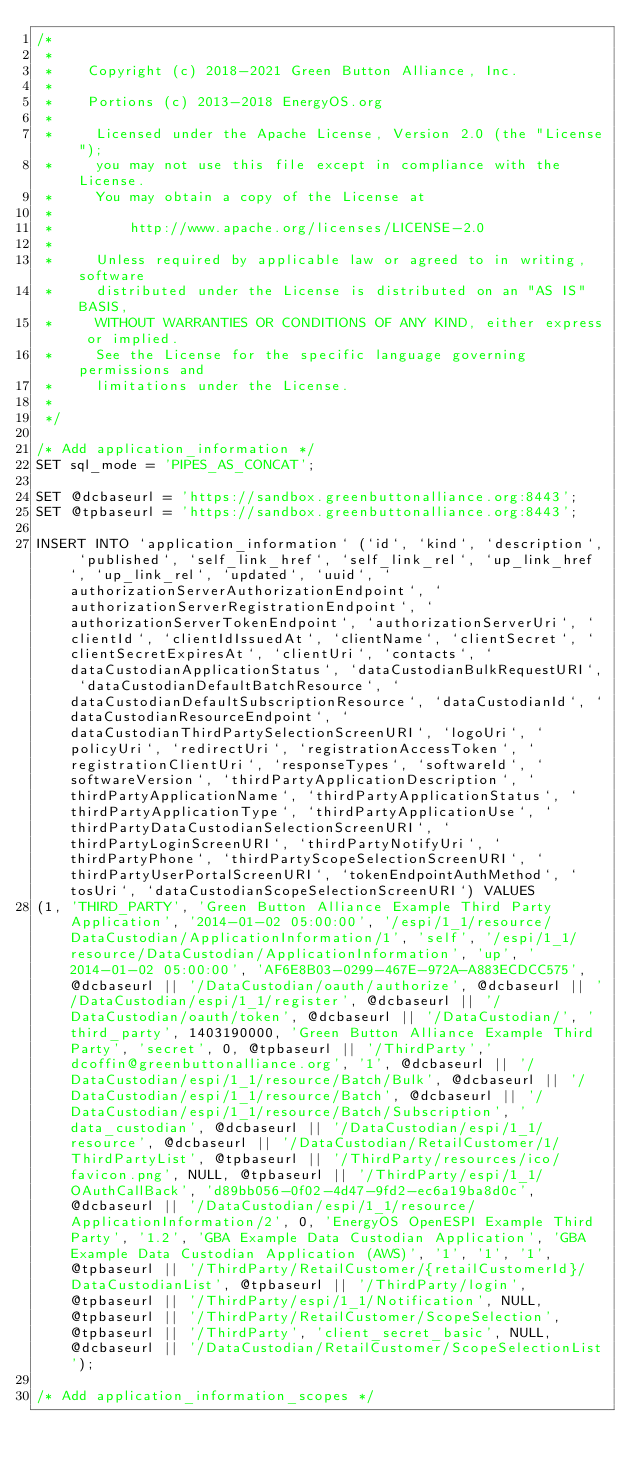<code> <loc_0><loc_0><loc_500><loc_500><_SQL_>/*
 *
 *    Copyright (c) 2018-2021 Green Button Alliance, Inc.
 *
 *    Portions (c) 2013-2018 EnergyOS.org
 *
 *     Licensed under the Apache License, Version 2.0 (the "License");
 *     you may not use this file except in compliance with the License.
 *     You may obtain a copy of the License at
 *
 *         http://www.apache.org/licenses/LICENSE-2.0
 *
 *     Unless required by applicable law or agreed to in writing, software
 *     distributed under the License is distributed on an "AS IS" BASIS,
 *     WITHOUT WARRANTIES OR CONDITIONS OF ANY KIND, either express or implied.
 *     See the License for the specific language governing permissions and
 *     limitations under the License.
 *
 */

/* Add application_information */
SET sql_mode = 'PIPES_AS_CONCAT';

SET @dcbaseurl = 'https://sandbox.greenbuttonalliance.org:8443';
SET @tpbaseurl = 'https://sandbox.greenbuttonalliance.org:8443';
 
INSERT INTO `application_information` (`id`, `kind`, `description`, `published`, `self_link_href`, `self_link_rel`, `up_link_href`, `up_link_rel`, `updated`, `uuid`, `authorizationServerAuthorizationEndpoint`, `authorizationServerRegistrationEndpoint`, `authorizationServerTokenEndpoint`, `authorizationServerUri`, `clientId`, `clientIdIssuedAt`, `clientName`, `clientSecret`, `clientSecretExpiresAt`, `clientUri`, `contacts`, `dataCustodianApplicationStatus`, `dataCustodianBulkRequestURI`, `dataCustodianDefaultBatchResource`, `dataCustodianDefaultSubscriptionResource`, `dataCustodianId`, `dataCustodianResourceEndpoint`, `dataCustodianThirdPartySelectionScreenURI`, `logoUri`, `policyUri`, `redirectUri`, `registrationAccessToken`, `registrationClientUri`, `responseTypes`, `softwareId`, `softwareVersion`, `thirdPartyApplicationDescription`, `thirdPartyApplicationName`, `thirdPartyApplicationStatus`, `thirdPartyApplicationType`, `thirdPartyApplicationUse`, `thirdPartyDataCustodianSelectionScreenURI`, `thirdPartyLoginScreenURI`, `thirdPartyNotifyUri`, `thirdPartyPhone`, `thirdPartyScopeSelectionScreenURI`, `thirdPartyUserPortalScreenURI`, `tokenEndpointAuthMethod`, `tosUri`, `dataCustodianScopeSelectionScreenURI`) VALUES
(1, 'THIRD_PARTY', 'Green Button Alliance Example Third Party Application', '2014-01-02 05:00:00', '/espi/1_1/resource/DataCustodian/ApplicationInformation/1', 'self', '/espi/1_1/resource/DataCustodian/ApplicationInformation', 'up', '2014-01-02 05:00:00', 'AF6E8B03-0299-467E-972A-A883ECDCC575', @dcbaseurl || '/DataCustodian/oauth/authorize', @dcbaseurl || '/DataCustodian/espi/1_1/register', @dcbaseurl || '/DataCustodian/oauth/token', @dcbaseurl || '/DataCustodian/', 'third_party', 1403190000, 'Green Button Alliance Example Third Party', 'secret', 0, @tpbaseurl || '/ThirdParty','dcoffin@greenbuttonalliance.org', '1', @dcbaseurl || '/DataCustodian/espi/1_1/resource/Batch/Bulk', @dcbaseurl || '/DataCustodian/espi/1_1/resource/Batch', @dcbaseurl || '/DataCustodian/espi/1_1/resource/Batch/Subscription', 'data_custodian', @dcbaseurl || '/DataCustodian/espi/1_1/resource', @dcbaseurl || '/DataCustodian/RetailCustomer/1/ThirdPartyList', @tpbaseurl || '/ThirdParty/resources/ico/favicon.png', NULL, @tpbaseurl || '/ThirdParty/espi/1_1/OAuthCallBack', 'd89bb056-0f02-4d47-9fd2-ec6a19ba8d0c', @dcbaseurl || '/DataCustodian/espi/1_1/resource/ApplicationInformation/2', 0, 'EnergyOS OpenESPI Example Third Party', '1.2', 'GBA Example Data Custodian Application', 'GBA Example Data Custodian Application (AWS)', '1', '1', '1', @tpbaseurl || '/ThirdParty/RetailCustomer/{retailCustomerId}/DataCustodianList', @tpbaseurl || '/ThirdParty/login', @tpbaseurl || '/ThirdParty/espi/1_1/Notification', NULL, @tpbaseurl || '/ThirdParty/RetailCustomer/ScopeSelection', @tpbaseurl || '/ThirdParty', 'client_secret_basic', NULL, @dcbaseurl || '/DataCustodian/RetailCustomer/ScopeSelectionList');

/* Add application_information_scopes */ </code> 